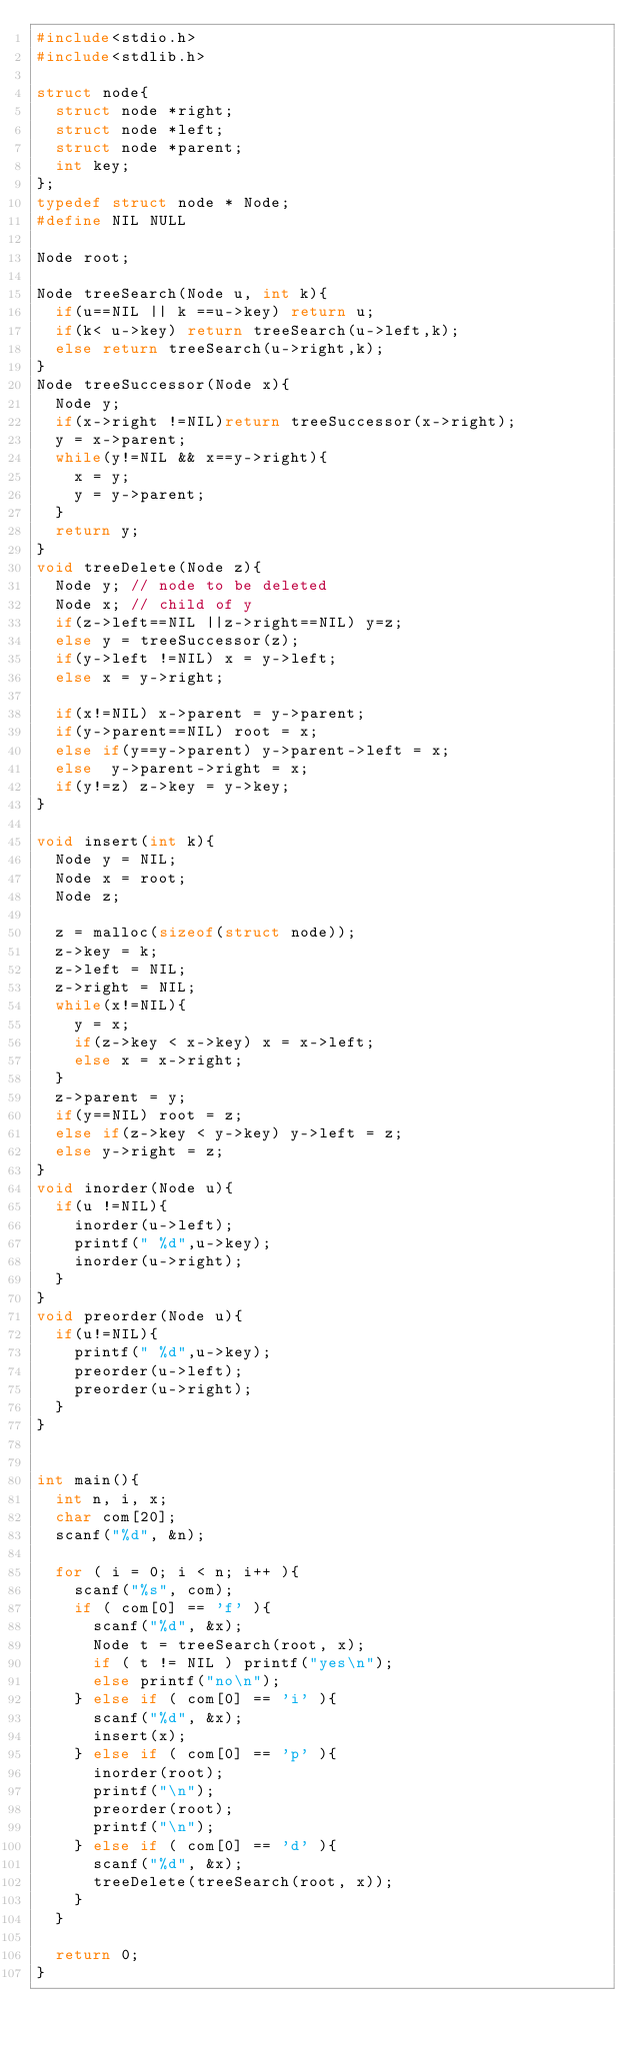Convert code to text. <code><loc_0><loc_0><loc_500><loc_500><_C_>#include<stdio.h>
#include<stdlib.h>

struct node{
  struct node *right;
  struct node *left;
  struct node *parent;
  int key;
};
typedef struct node * Node;
#define NIL NULL

Node root;

Node treeSearch(Node u, int k){
  if(u==NIL || k ==u->key) return u;
  if(k< u->key) return treeSearch(u->left,k);
  else return treeSearch(u->right,k);
}
Node treeSuccessor(Node x){
  Node y;
  if(x->right !=NIL)return treeSuccessor(x->right);
  y = x->parent;
  while(y!=NIL && x==y->right){
    x = y;
    y = y->parent;
  }
  return y;
}
void treeDelete(Node z){
  Node y; // node to be deleted
  Node x; // child of y
  if(z->left==NIL ||z->right==NIL) y=z;
  else y = treeSuccessor(z);
  if(y->left !=NIL) x = y->left;
  else x = y->right;

  if(x!=NIL) x->parent = y->parent;
  if(y->parent==NIL) root = x;
  else if(y==y->parent) y->parent->left = x;
  else  y->parent->right = x;
  if(y!=z) z->key = y->key;
}

void insert(int k){
  Node y = NIL;
  Node x = root;
  Node z;

  z = malloc(sizeof(struct node));
  z->key = k;
  z->left = NIL;
  z->right = NIL;
  while(x!=NIL){
    y = x;
    if(z->key < x->key) x = x->left;
    else x = x->right;
  }
  z->parent = y;
  if(y==NIL) root = z;
  else if(z->key < y->key) y->left = z;
  else y->right = z;
}
void inorder(Node u){
  if(u !=NIL){
    inorder(u->left);
    printf(" %d",u->key);
    inorder(u->right);
  }
}
void preorder(Node u){
  if(u!=NIL){
    printf(" %d",u->key);
    preorder(u->left);
    preorder(u->right);
  }
}


int main(){
  int n, i, x;
  char com[20];
  scanf("%d", &n);

  for ( i = 0; i < n; i++ ){
    scanf("%s", com);
    if ( com[0] == 'f' ){
      scanf("%d", &x);
      Node t = treeSearch(root, x);
      if ( t != NIL ) printf("yes\n");
      else printf("no\n");
    } else if ( com[0] == 'i' ){
      scanf("%d", &x);
      insert(x);
    } else if ( com[0] == 'p' ){
      inorder(root);
      printf("\n");
      preorder(root);
      printf("\n");
    } else if ( com[0] == 'd' ){
      scanf("%d", &x);
      treeDelete(treeSearch(root, x));
    }
  }

  return 0;
}</code> 